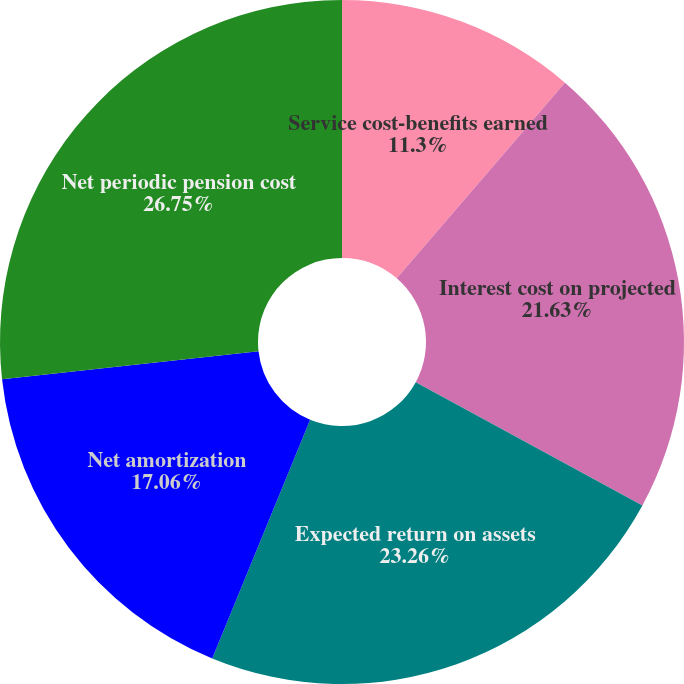Convert chart to OTSL. <chart><loc_0><loc_0><loc_500><loc_500><pie_chart><fcel>Service cost-benefits earned<fcel>Interest cost on projected<fcel>Expected return on assets<fcel>Net amortization<fcel>Net periodic pension cost<nl><fcel>11.3%<fcel>21.63%<fcel>23.26%<fcel>17.06%<fcel>26.74%<nl></chart> 